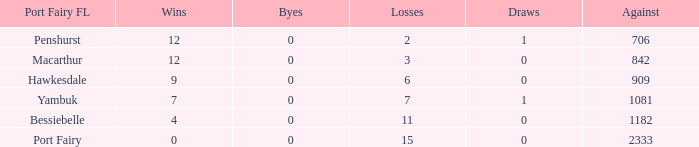When hawkesdale achieves greater than 9 wins in the port fairy fl, what is the number of draws? None. 